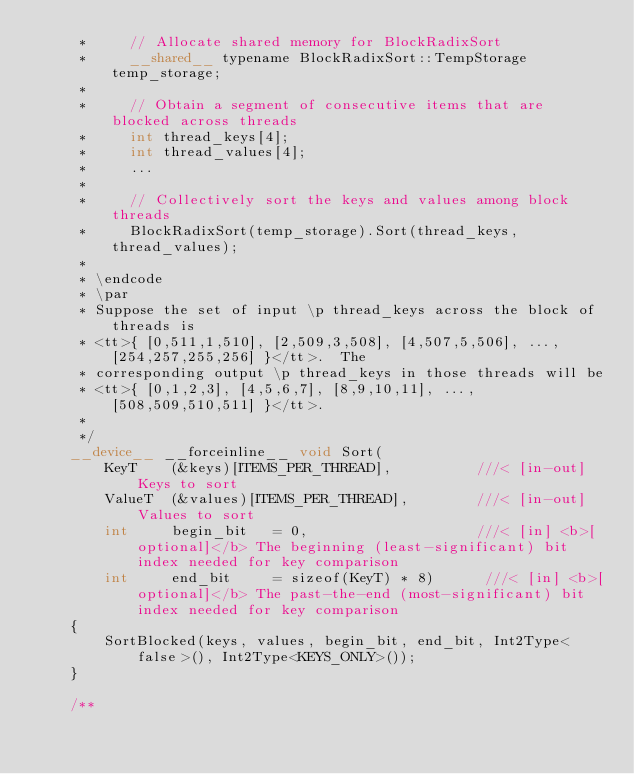<code> <loc_0><loc_0><loc_500><loc_500><_Cuda_>     *     // Allocate shared memory for BlockRadixSort
     *     __shared__ typename BlockRadixSort::TempStorage temp_storage;
     *
     *     // Obtain a segment of consecutive items that are blocked across threads
     *     int thread_keys[4];
     *     int thread_values[4];
     *     ...
     *
     *     // Collectively sort the keys and values among block threads
     *     BlockRadixSort(temp_storage).Sort(thread_keys, thread_values);
     *
     * \endcode
     * \par
     * Suppose the set of input \p thread_keys across the block of threads is
     * <tt>{ [0,511,1,510], [2,509,3,508], [4,507,5,506], ..., [254,257,255,256] }</tt>.  The
     * corresponding output \p thread_keys in those threads will be
     * <tt>{ [0,1,2,3], [4,5,6,7], [8,9,10,11], ..., [508,509,510,511] }</tt>.
     *
     */
    __device__ __forceinline__ void Sort(
        KeyT    (&keys)[ITEMS_PER_THREAD],          ///< [in-out] Keys to sort
        ValueT  (&values)[ITEMS_PER_THREAD],        ///< [in-out] Values to sort
        int     begin_bit   = 0,                    ///< [in] <b>[optional]</b> The beginning (least-significant) bit index needed for key comparison
        int     end_bit     = sizeof(KeyT) * 8)      ///< [in] <b>[optional]</b> The past-the-end (most-significant) bit index needed for key comparison
    {
        SortBlocked(keys, values, begin_bit, end_bit, Int2Type<false>(), Int2Type<KEYS_ONLY>());
    }

    /**</code> 